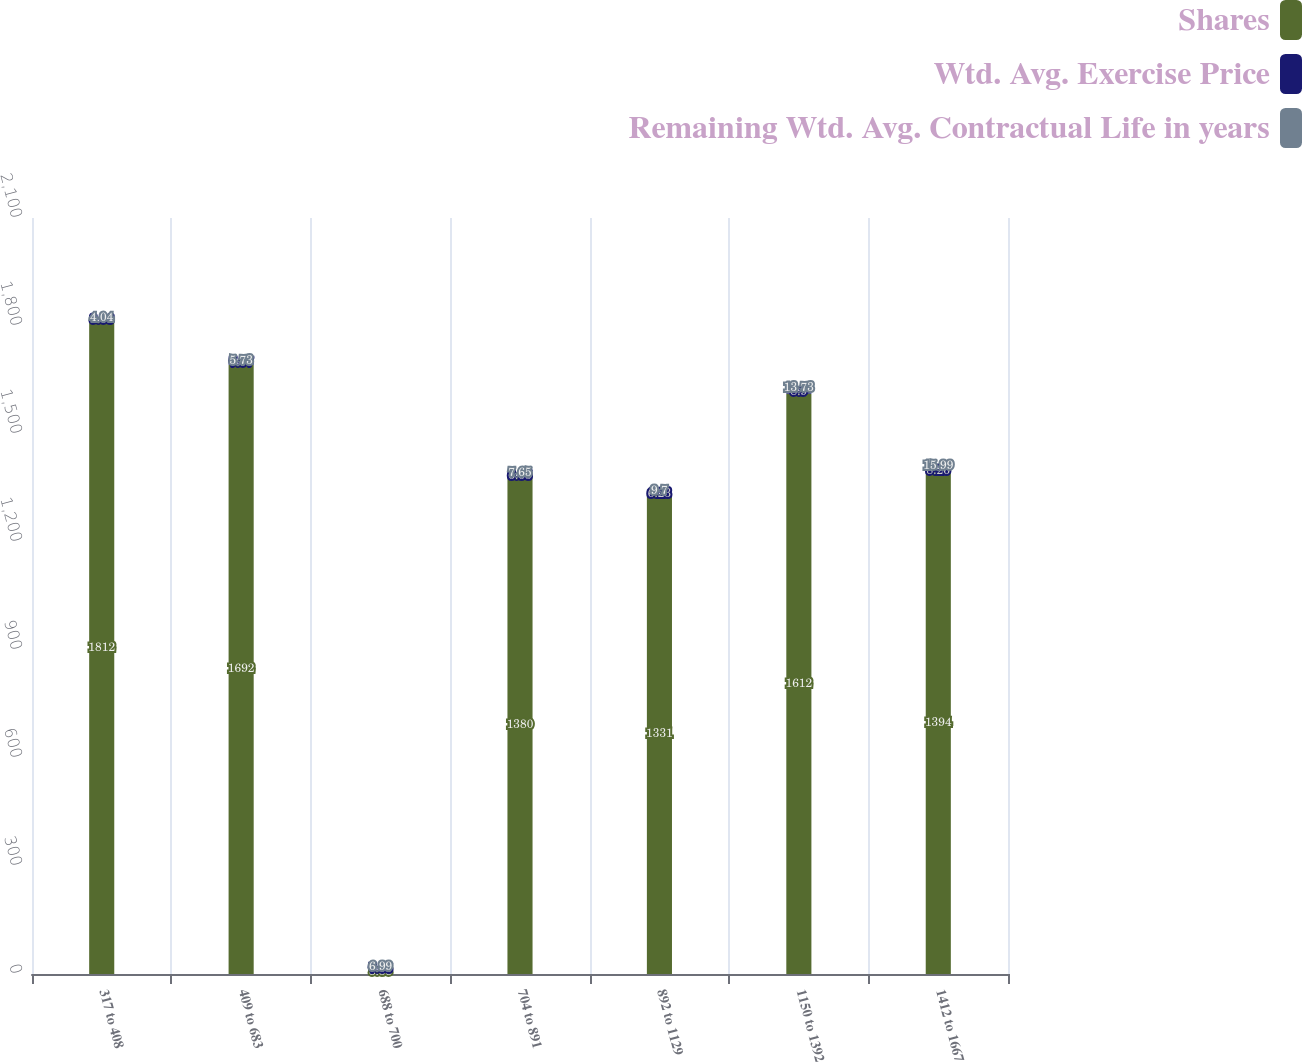Convert chart to OTSL. <chart><loc_0><loc_0><loc_500><loc_500><stacked_bar_chart><ecel><fcel>317 to 408<fcel>409 to 683<fcel>688 to 700<fcel>704 to 891<fcel>892 to 1129<fcel>1150 to 1392<fcel>1412 to 1667<nl><fcel>Shares<fcel>1812<fcel>1692<fcel>8.58<fcel>1380<fcel>1331<fcel>1612<fcel>1394<nl><fcel>Wtd. Avg. Exercise Price<fcel>8.06<fcel>7.07<fcel>7.05<fcel>6.65<fcel>6.23<fcel>8.9<fcel>8.26<nl><fcel>Remaining Wtd. Avg. Contractual Life in years<fcel>4.04<fcel>5.73<fcel>6.99<fcel>7.65<fcel>9.7<fcel>13.73<fcel>15.99<nl></chart> 